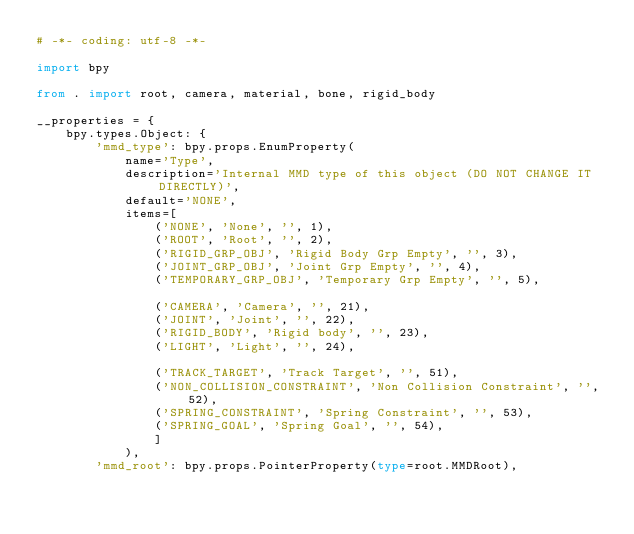<code> <loc_0><loc_0><loc_500><loc_500><_Python_># -*- coding: utf-8 -*-

import bpy

from . import root, camera, material, bone, rigid_body

__properties = {
    bpy.types.Object: {
        'mmd_type': bpy.props.EnumProperty(
            name='Type',
            description='Internal MMD type of this object (DO NOT CHANGE IT DIRECTLY)',
            default='NONE',
            items=[
                ('NONE', 'None', '', 1),
                ('ROOT', 'Root', '', 2),
                ('RIGID_GRP_OBJ', 'Rigid Body Grp Empty', '', 3),
                ('JOINT_GRP_OBJ', 'Joint Grp Empty', '', 4),
                ('TEMPORARY_GRP_OBJ', 'Temporary Grp Empty', '', 5),

                ('CAMERA', 'Camera', '', 21),
                ('JOINT', 'Joint', '', 22),
                ('RIGID_BODY', 'Rigid body', '', 23),
                ('LIGHT', 'Light', '', 24),

                ('TRACK_TARGET', 'Track Target', '', 51),
                ('NON_COLLISION_CONSTRAINT', 'Non Collision Constraint', '', 52),
                ('SPRING_CONSTRAINT', 'Spring Constraint', '', 53),
                ('SPRING_GOAL', 'Spring Goal', '', 54),
                ]
            ),
        'mmd_root': bpy.props.PointerProperty(type=root.MMDRoot),</code> 